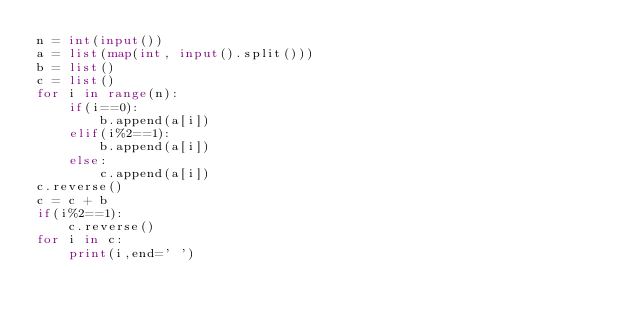Convert code to text. <code><loc_0><loc_0><loc_500><loc_500><_Python_>n = int(input())
a = list(map(int, input().split()))
b = list()
c = list()
for i in range(n):
    if(i==0):
        b.append(a[i])
    elif(i%2==1):
        b.append(a[i])
    else:
        c.append(a[i])
c.reverse()
c = c + b
if(i%2==1):
    c.reverse()
for i in c:
    print(i,end=' ')</code> 